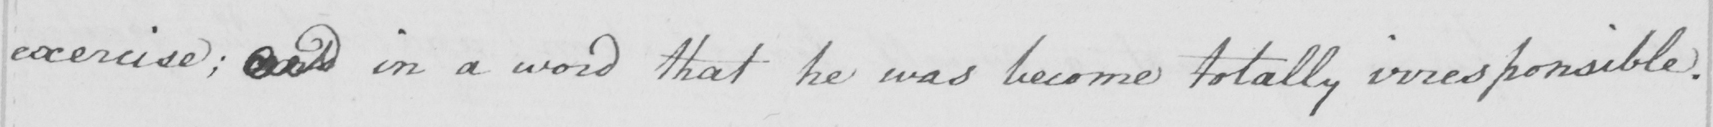What is written in this line of handwriting? exercise ; and in a word that he was become totally irresponsible . 